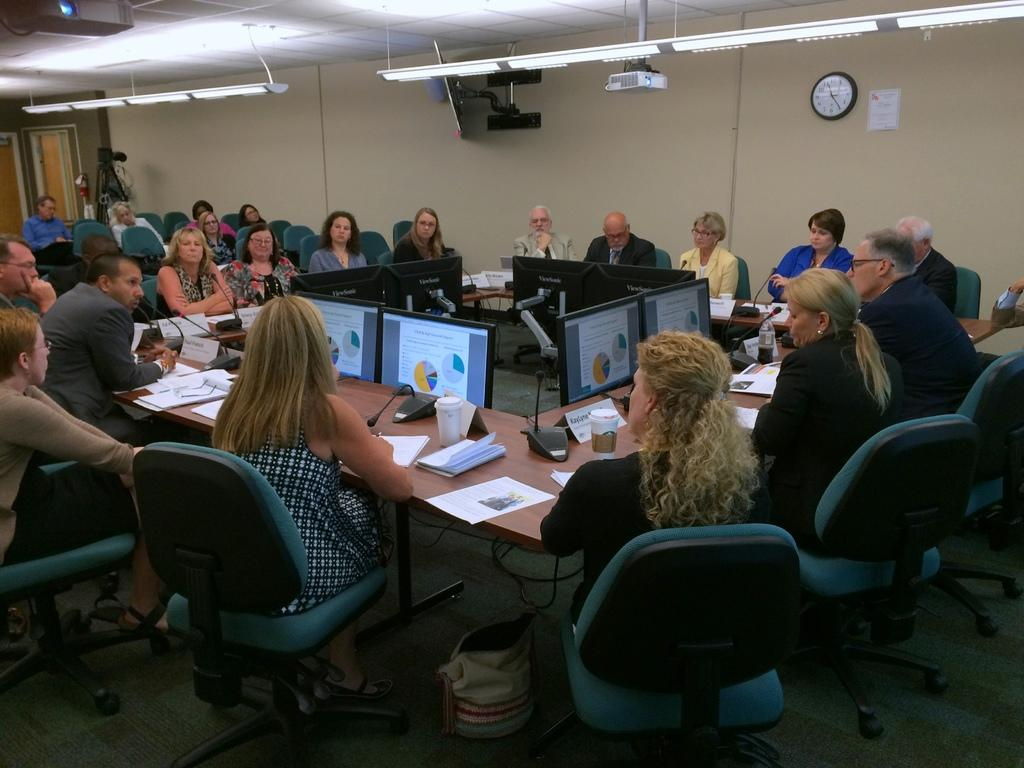What is the main subject of the image? The main subject of the image is a crowd. How are the people in the crowd positioned? The crowd is sitting on tables. What can be seen around the crowd? There are monitors around the crowd. What is visible on the wall in the image? There is a clock on the wall in the image. How many chickens are present in the image? There are no chickens present in the image; the main subject is a crowd of people sitting on tables. What type of bone can be seen being used as a measuring tool in the image? There is no bone present in the image, nor is there any measuring tool visible. 